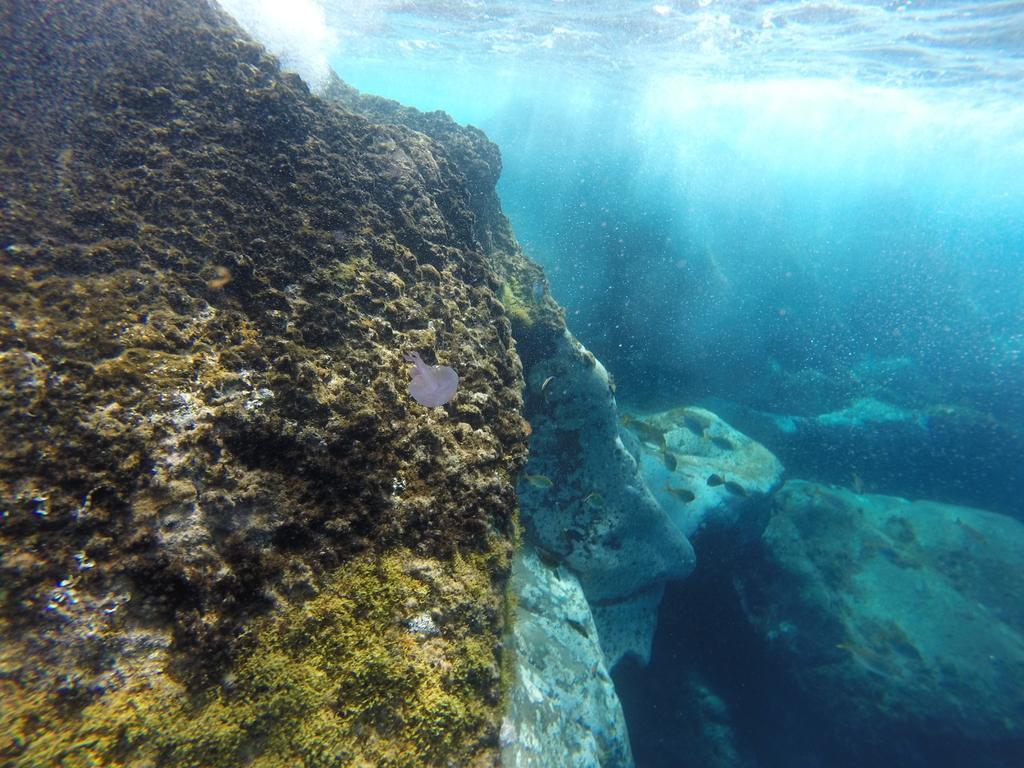Describe this image in one or two sentences. This picture is consists of underwater view. 